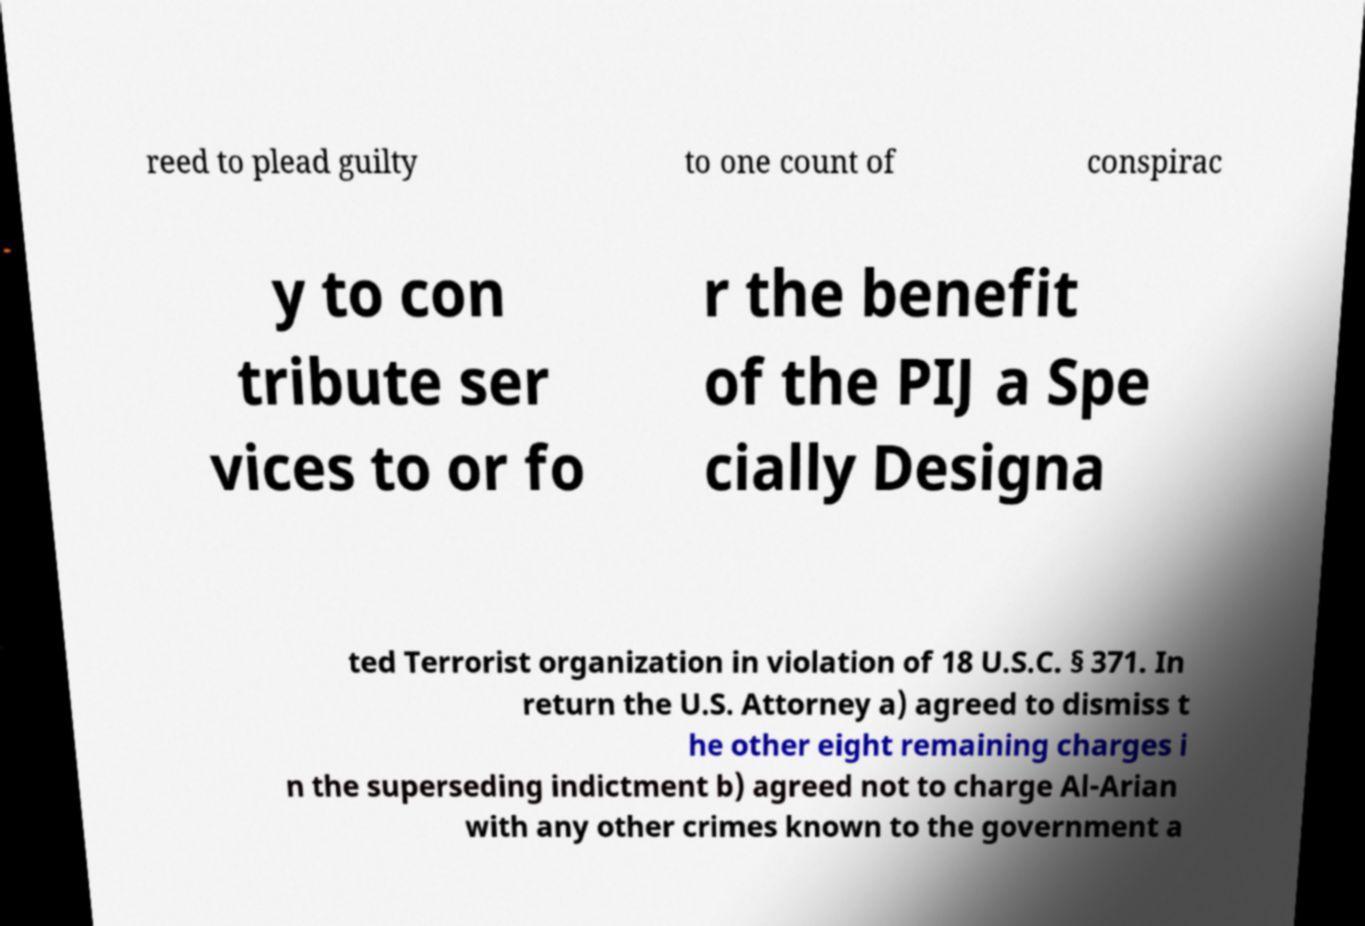There's text embedded in this image that I need extracted. Can you transcribe it verbatim? reed to plead guilty to one count of conspirac y to con tribute ser vices to or fo r the benefit of the PIJ a Spe cially Designa ted Terrorist organization in violation of 18 U.S.C. § 371. In return the U.S. Attorney a) agreed to dismiss t he other eight remaining charges i n the superseding indictment b) agreed not to charge Al-Arian with any other crimes known to the government a 